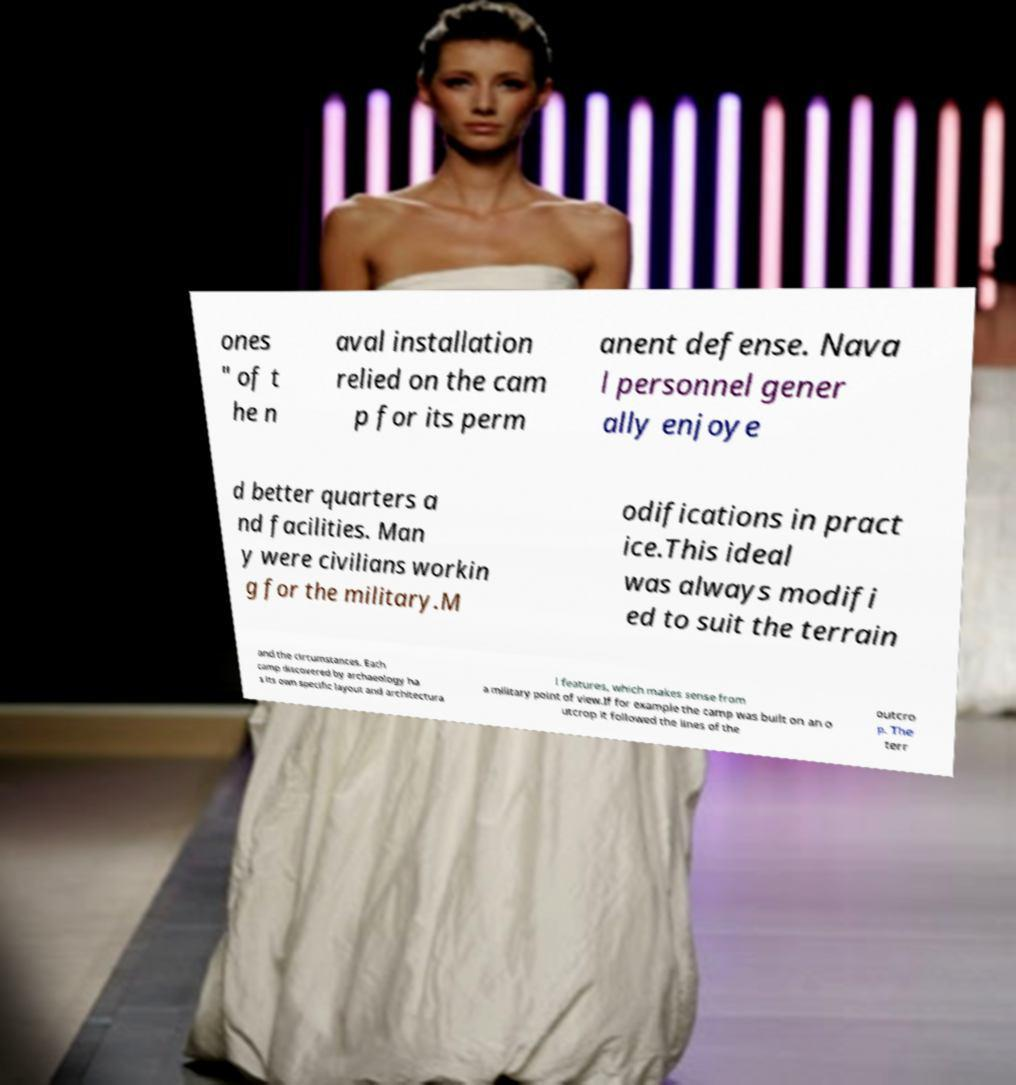I need the written content from this picture converted into text. Can you do that? ones " of t he n aval installation relied on the cam p for its perm anent defense. Nava l personnel gener ally enjoye d better quarters a nd facilities. Man y were civilians workin g for the military.M odifications in pract ice.This ideal was always modifi ed to suit the terrain and the circumstances. Each camp discovered by archaeology ha s its own specific layout and architectura l features, which makes sense from a military point of view.If for example the camp was built on an o utcrop it followed the lines of the outcro p. The terr 